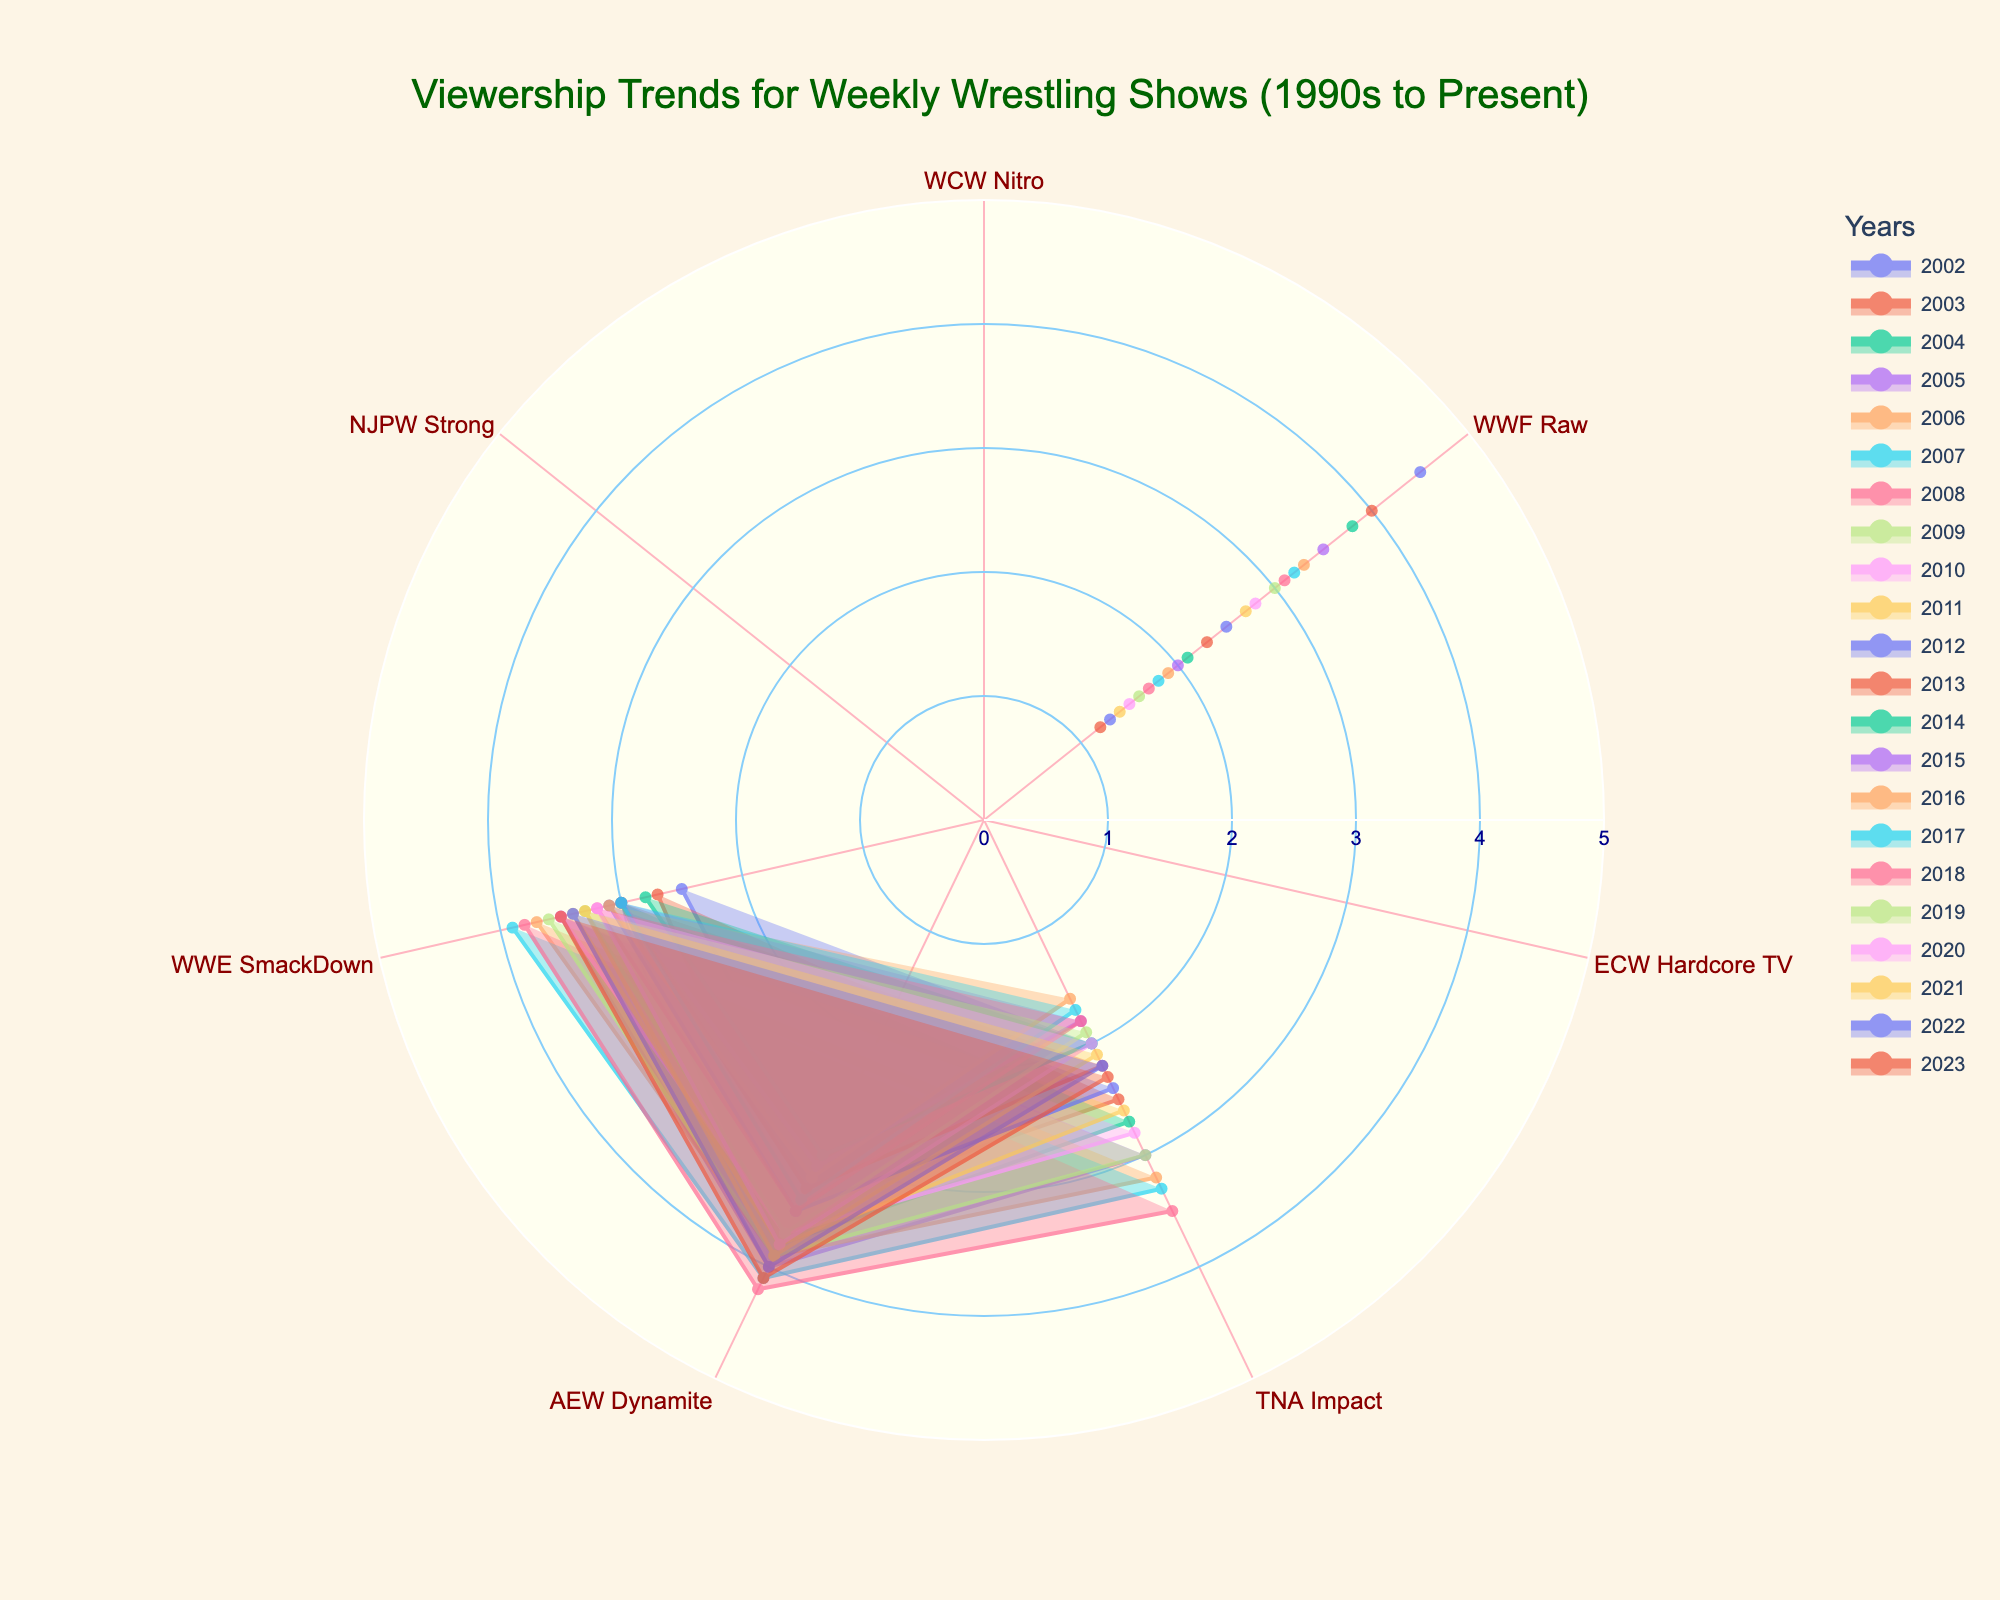What's the highest viewership value for any show in 2007? Look at the 2007 plot to find the highest point on the radar chart. The highest value is 4.1 for AEW Dynamite.
Answer: 4.1 How many wrestling shows had their highest viewership in 2023? Find the 2023 plot and count the number of shows reaching their highest point in that year compared to others. Only TNA Impact has its highest viewership of 4.1 in 2023.
Answer: 1 Which show had a consistent drop in viewership from 2002 to 2023? Look at each year’s plots to identify the show with a consistently declining trend. WWF Raw shows a consistent decline from 4.5 in 2002 to 1.2 in 2023.
Answer: WWF Raw Compare the viewership trend between AEW Dynamite and WWE SmackDown from 2010 to 2023. Which show had higher viewership in more years? Compare the radar chart segments for each show across the specified years to count how many years each had higher values. AEW Dynamite had higher values more frequently than WWE SmackDown in those years.
Answer: AEW Dynamite What's the difference in viewership between AEW Dynamite and TNA Impact in 2015? Locate 2015 plot points for both shows and calculate the difference: AEW Dynamite (3.1) - TNA Impact (1.8) = 1.3
Answer: 1.3 What is the average viewership of WWE SmackDown from 2005 to 2010? Sum up the values of WWE SmackDown from 2005 to 2010 and divide by the number of years: (3.5 + 3.7 + 3.9 + 4.2 + 3.9 + 3.7)/6 ≈ 3.82
Answer: 3.82 Do any shows have a viewership value of 3.0 in 2009? Look at the 2009 plot and check if any show's value reaches 3.0. TNA Impact and WWE SmackDown both have a viewership of 3.0 in 2009.
Answer: TNA Impact, WWE SmackDown In which year did WWF Raw drop below a viewership of 2.0? Find the point in the radar chart where WWF Raw's viewership fell below 2.0. The year is 2017 with 1.9.
Answer: 2017 Is there any year in which all shows had over 3.0 viewership? Check each year’s plot to see if all show values are above 3.0. No year has all shows with viewership over 3.0.
Answer: No 